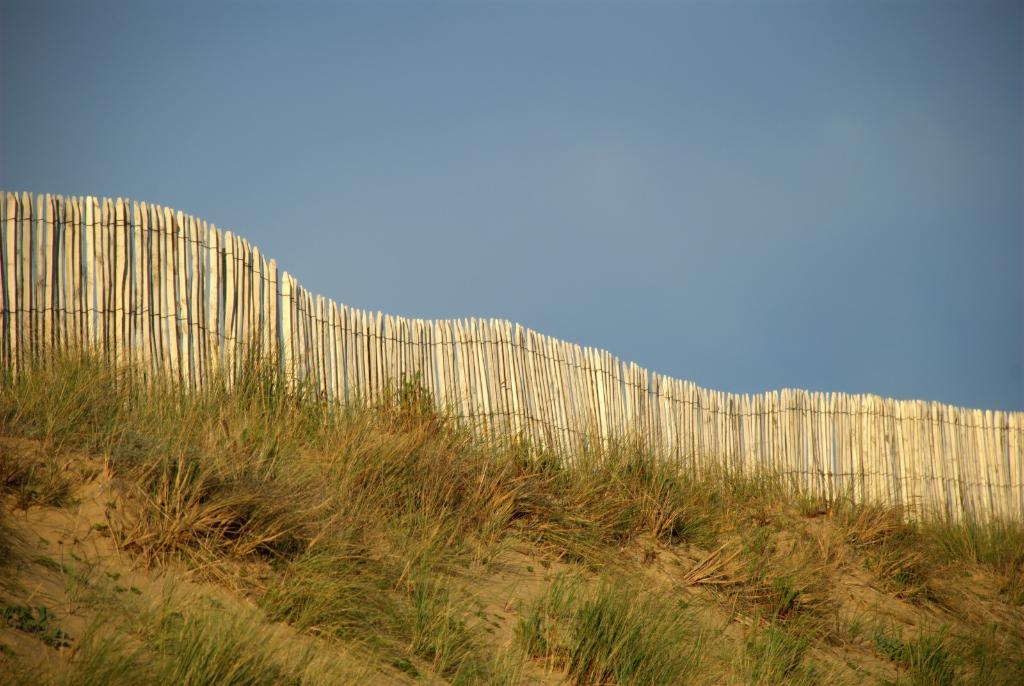What type of vegetation is in the foreground of the image? There is grass in the foreground of the image. What structure is also present in the foreground of the image? There is a wooden railing in the foreground of the image. What is visible at the top of the image? The sky is visible at the top of the image. Can you describe the creature that is helping the fireman in the image? There is no creature or fireman present in the image; it only features grass and a wooden railing in the foreground and the sky at the top. 